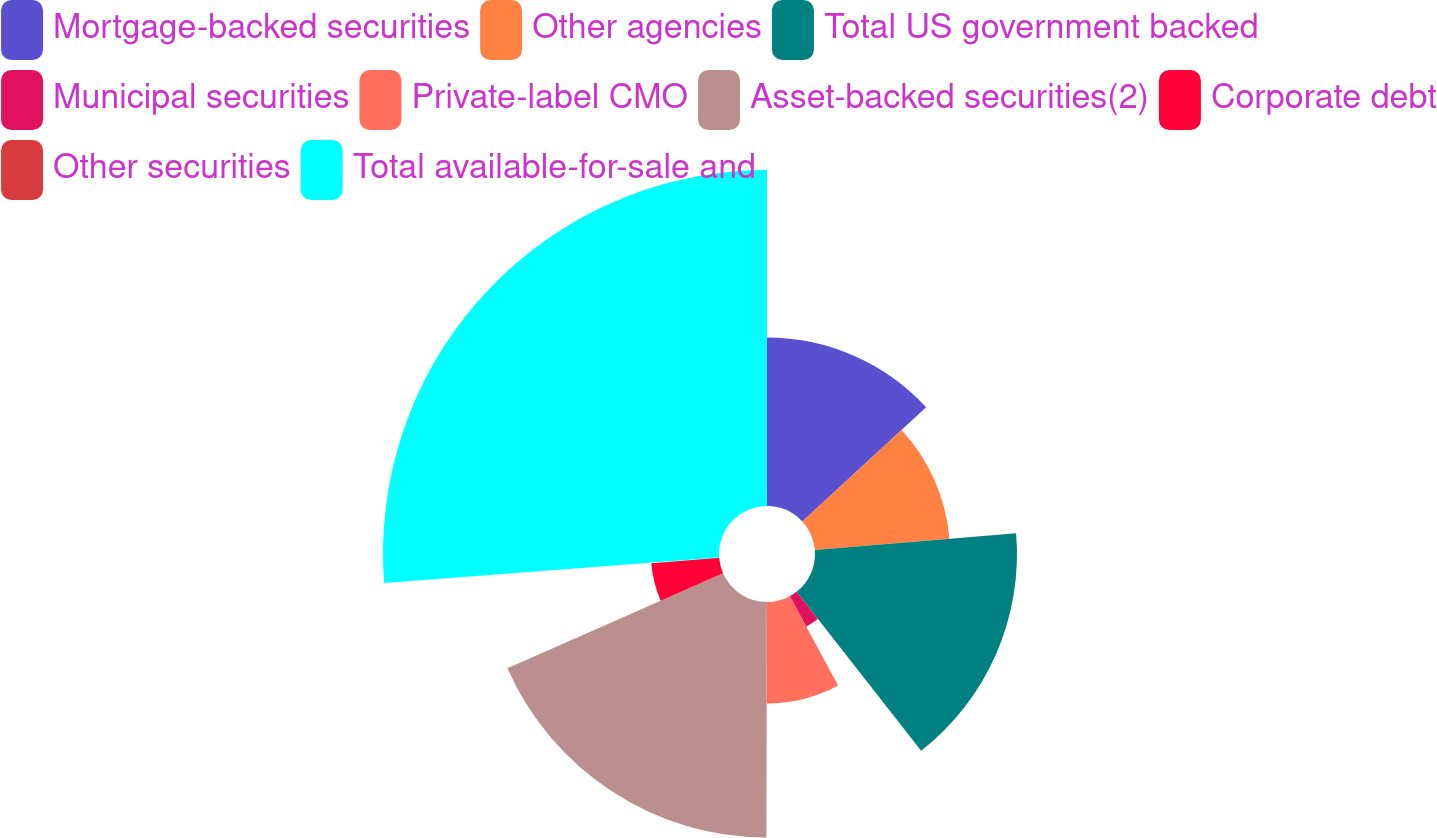Convert chart to OTSL. <chart><loc_0><loc_0><loc_500><loc_500><pie_chart><fcel>Mortgage-backed securities<fcel>Other agencies<fcel>Total US government backed<fcel>Municipal securities<fcel>Private-label CMO<fcel>Asset-backed securities(2)<fcel>Corporate debt<fcel>Other securities<fcel>Total available-for-sale and<nl><fcel>13.14%<fcel>10.53%<fcel>15.75%<fcel>2.69%<fcel>7.92%<fcel>18.37%<fcel>5.31%<fcel>0.08%<fcel>26.2%<nl></chart> 